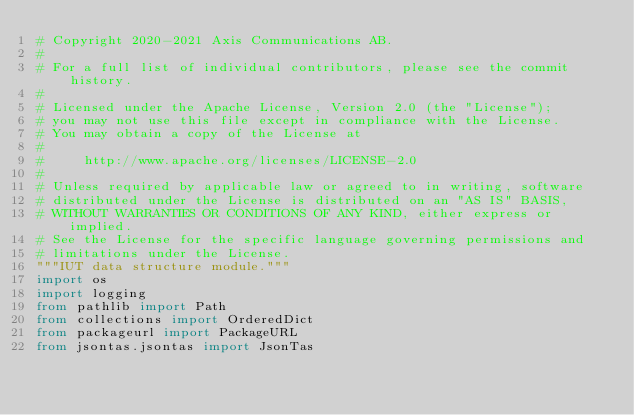<code> <loc_0><loc_0><loc_500><loc_500><_Python_># Copyright 2020-2021 Axis Communications AB.
#
# For a full list of individual contributors, please see the commit history.
#
# Licensed under the Apache License, Version 2.0 (the "License");
# you may not use this file except in compliance with the License.
# You may obtain a copy of the License at
#
#     http://www.apache.org/licenses/LICENSE-2.0
#
# Unless required by applicable law or agreed to in writing, software
# distributed under the License is distributed on an "AS IS" BASIS,
# WITHOUT WARRANTIES OR CONDITIONS OF ANY KIND, either express or implied.
# See the License for the specific language governing permissions and
# limitations under the License.
"""IUT data structure module."""
import os
import logging
from pathlib import Path
from collections import OrderedDict
from packageurl import PackageURL
from jsontas.jsontas import JsonTas</code> 